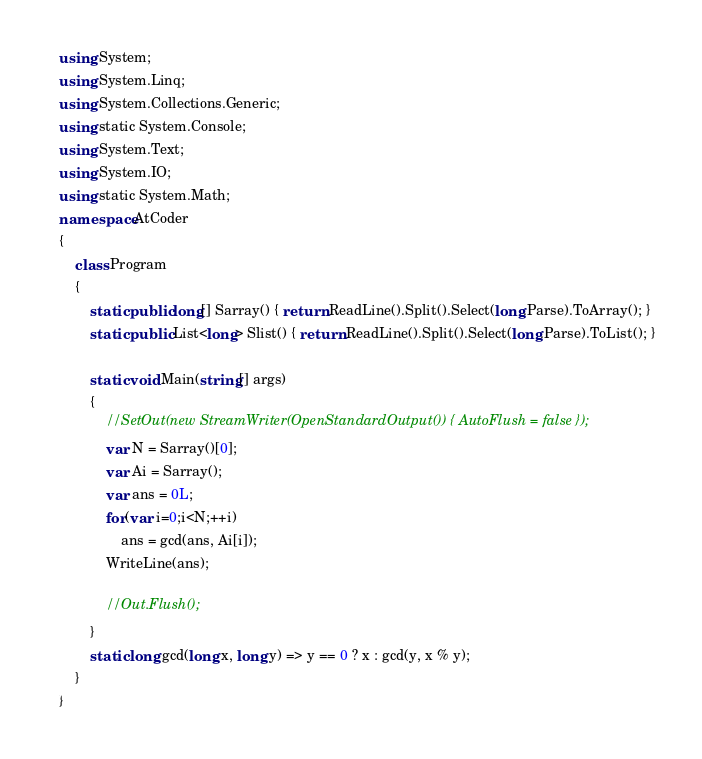Convert code to text. <code><loc_0><loc_0><loc_500><loc_500><_C#_>using System;
using System.Linq;
using System.Collections.Generic;
using static System.Console;
using System.Text;
using System.IO;
using static System.Math;
namespace AtCoder
{
    class Program
    {
        static public long[] Sarray() { return ReadLine().Split().Select(long.Parse).ToArray(); }
        static public List<long> Slist() { return ReadLine().Split().Select(long.Parse).ToList(); }

        static void Main(string[] args)
        {
            //SetOut(new StreamWriter(OpenStandardOutput()) { AutoFlush = false });
            var N = Sarray()[0];
            var Ai = Sarray();
            var ans = 0L;
            for(var i=0;i<N;++i)
                ans = gcd(ans, Ai[i]);
            WriteLine(ans);

            //Out.Flush();
        }
        static long gcd(long x, long y) => y == 0 ? x : gcd(y, x % y);
    }
}</code> 